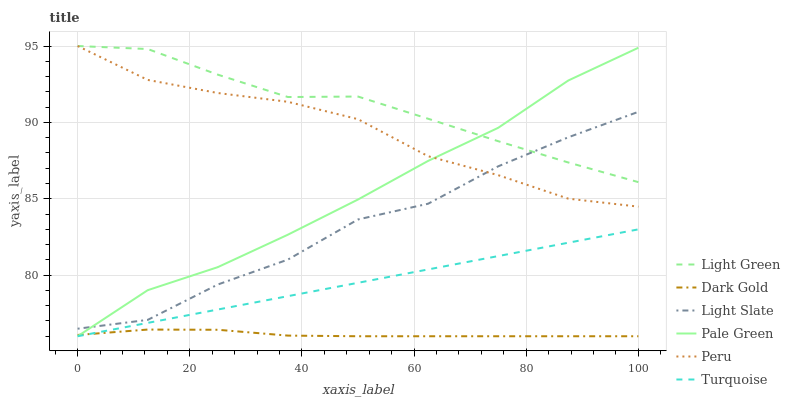Does Dark Gold have the minimum area under the curve?
Answer yes or no. Yes. Does Light Green have the maximum area under the curve?
Answer yes or no. Yes. Does Light Green have the minimum area under the curve?
Answer yes or no. No. Does Dark Gold have the maximum area under the curve?
Answer yes or no. No. Is Turquoise the smoothest?
Answer yes or no. Yes. Is Light Slate the roughest?
Answer yes or no. Yes. Is Light Green the smoothest?
Answer yes or no. No. Is Light Green the roughest?
Answer yes or no. No. Does Light Green have the lowest value?
Answer yes or no. No. Does Peru have the highest value?
Answer yes or no. Yes. Does Dark Gold have the highest value?
Answer yes or no. No. Is Turquoise less than Light Green?
Answer yes or no. Yes. Is Light Green greater than Turquoise?
Answer yes or no. Yes. Does Light Green intersect Light Slate?
Answer yes or no. Yes. Is Light Green less than Light Slate?
Answer yes or no. No. Is Light Green greater than Light Slate?
Answer yes or no. No. Does Turquoise intersect Light Green?
Answer yes or no. No. 